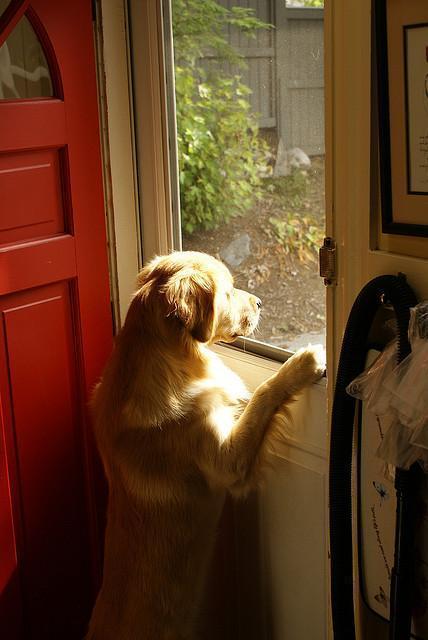How many dogs?
Give a very brief answer. 1. How many people are holding camera?
Give a very brief answer. 0. 